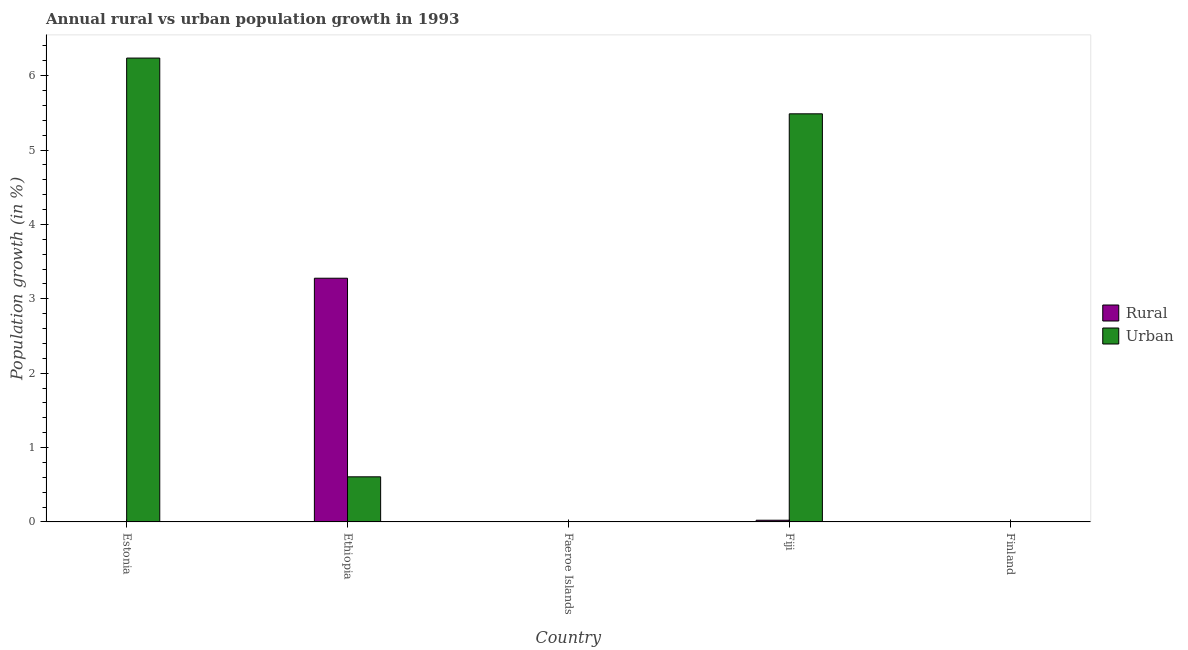Are the number of bars per tick equal to the number of legend labels?
Offer a very short reply. No. Are the number of bars on each tick of the X-axis equal?
Your response must be concise. No. How many bars are there on the 2nd tick from the left?
Offer a terse response. 2. How many bars are there on the 5th tick from the right?
Give a very brief answer. 1. What is the label of the 3rd group of bars from the left?
Your response must be concise. Faeroe Islands. What is the rural population growth in Ethiopia?
Give a very brief answer. 3.28. Across all countries, what is the maximum urban population growth?
Your response must be concise. 6.24. In which country was the rural population growth maximum?
Provide a short and direct response. Ethiopia. What is the total urban population growth in the graph?
Your answer should be very brief. 12.33. What is the difference between the urban population growth in Estonia and that in Fiji?
Provide a short and direct response. 0.75. What is the average urban population growth per country?
Give a very brief answer. 2.47. What is the difference between the rural population growth and urban population growth in Fiji?
Your answer should be compact. -5.46. What is the ratio of the urban population growth in Estonia to that in Fiji?
Make the answer very short. 1.14. What is the difference between the highest and the lowest urban population growth?
Provide a succinct answer. 6.24. How many countries are there in the graph?
Make the answer very short. 5. What is the difference between two consecutive major ticks on the Y-axis?
Your answer should be compact. 1. Are the values on the major ticks of Y-axis written in scientific E-notation?
Provide a succinct answer. No. Does the graph contain any zero values?
Make the answer very short. Yes. Where does the legend appear in the graph?
Provide a succinct answer. Center right. How many legend labels are there?
Make the answer very short. 2. How are the legend labels stacked?
Provide a short and direct response. Vertical. What is the title of the graph?
Offer a terse response. Annual rural vs urban population growth in 1993. What is the label or title of the Y-axis?
Provide a succinct answer. Population growth (in %). What is the Population growth (in %) in Urban  in Estonia?
Offer a very short reply. 6.24. What is the Population growth (in %) in Rural in Ethiopia?
Offer a very short reply. 3.28. What is the Population growth (in %) of Urban  in Ethiopia?
Your response must be concise. 0.61. What is the Population growth (in %) in Rural in Fiji?
Offer a terse response. 0.02. What is the Population growth (in %) of Urban  in Fiji?
Ensure brevity in your answer.  5.49. What is the Population growth (in %) of Rural in Finland?
Provide a succinct answer. 0. What is the Population growth (in %) of Urban  in Finland?
Ensure brevity in your answer.  0. Across all countries, what is the maximum Population growth (in %) of Rural?
Give a very brief answer. 3.28. Across all countries, what is the maximum Population growth (in %) in Urban ?
Provide a short and direct response. 6.24. Across all countries, what is the minimum Population growth (in %) of Urban ?
Offer a very short reply. 0. What is the total Population growth (in %) in Rural in the graph?
Provide a succinct answer. 3.3. What is the total Population growth (in %) of Urban  in the graph?
Provide a short and direct response. 12.33. What is the difference between the Population growth (in %) of Urban  in Estonia and that in Ethiopia?
Provide a short and direct response. 5.63. What is the difference between the Population growth (in %) of Urban  in Estonia and that in Fiji?
Offer a terse response. 0.75. What is the difference between the Population growth (in %) of Rural in Ethiopia and that in Fiji?
Give a very brief answer. 3.25. What is the difference between the Population growth (in %) in Urban  in Ethiopia and that in Fiji?
Keep it short and to the point. -4.88. What is the difference between the Population growth (in %) of Rural in Ethiopia and the Population growth (in %) of Urban  in Fiji?
Ensure brevity in your answer.  -2.21. What is the average Population growth (in %) of Rural per country?
Your response must be concise. 0.66. What is the average Population growth (in %) of Urban  per country?
Your response must be concise. 2.47. What is the difference between the Population growth (in %) in Rural and Population growth (in %) in Urban  in Ethiopia?
Your response must be concise. 2.67. What is the difference between the Population growth (in %) in Rural and Population growth (in %) in Urban  in Fiji?
Give a very brief answer. -5.46. What is the ratio of the Population growth (in %) in Urban  in Estonia to that in Ethiopia?
Your response must be concise. 10.28. What is the ratio of the Population growth (in %) of Urban  in Estonia to that in Fiji?
Provide a succinct answer. 1.14. What is the ratio of the Population growth (in %) of Rural in Ethiopia to that in Fiji?
Offer a terse response. 144.47. What is the ratio of the Population growth (in %) in Urban  in Ethiopia to that in Fiji?
Offer a very short reply. 0.11. What is the difference between the highest and the second highest Population growth (in %) in Urban ?
Your response must be concise. 0.75. What is the difference between the highest and the lowest Population growth (in %) in Rural?
Your answer should be very brief. 3.28. What is the difference between the highest and the lowest Population growth (in %) of Urban ?
Offer a terse response. 6.24. 